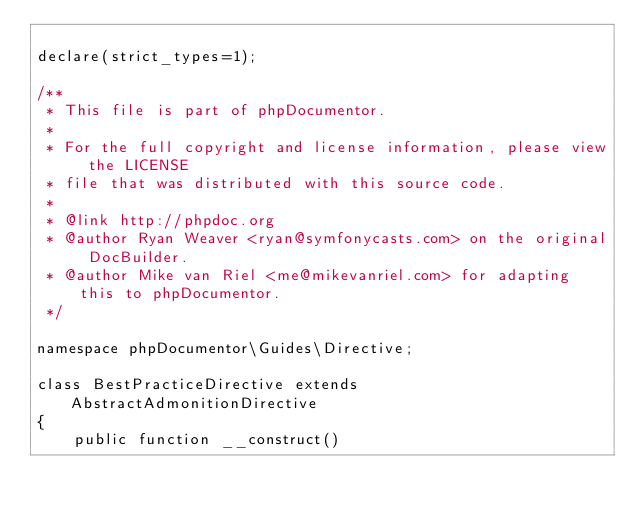Convert code to text. <code><loc_0><loc_0><loc_500><loc_500><_PHP_>
declare(strict_types=1);

/**
 * This file is part of phpDocumentor.
 *
 * For the full copyright and license information, please view the LICENSE
 * file that was distributed with this source code.
 *
 * @link http://phpdoc.org
 * @author Ryan Weaver <ryan@symfonycasts.com> on the original DocBuilder.
 * @author Mike van Riel <me@mikevanriel.com> for adapting this to phpDocumentor.
 */

namespace phpDocumentor\Guides\Directive;

class BestPracticeDirective extends AbstractAdmonitionDirective
{
    public function __construct()</code> 